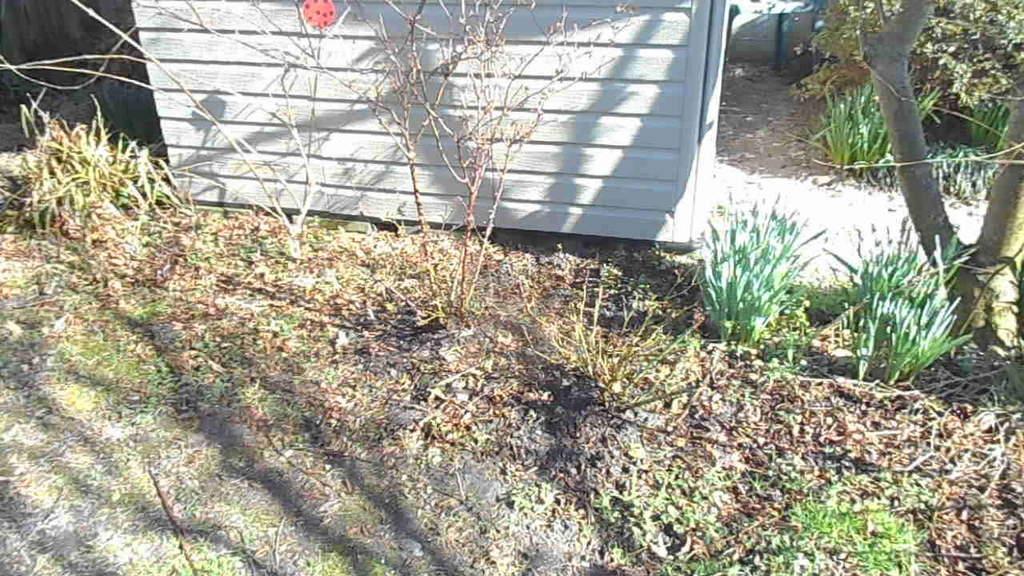Can you describe this image briefly? In the center of the image there is a shed. On the right there is a tree. At the bottom we can see plants and grass. 